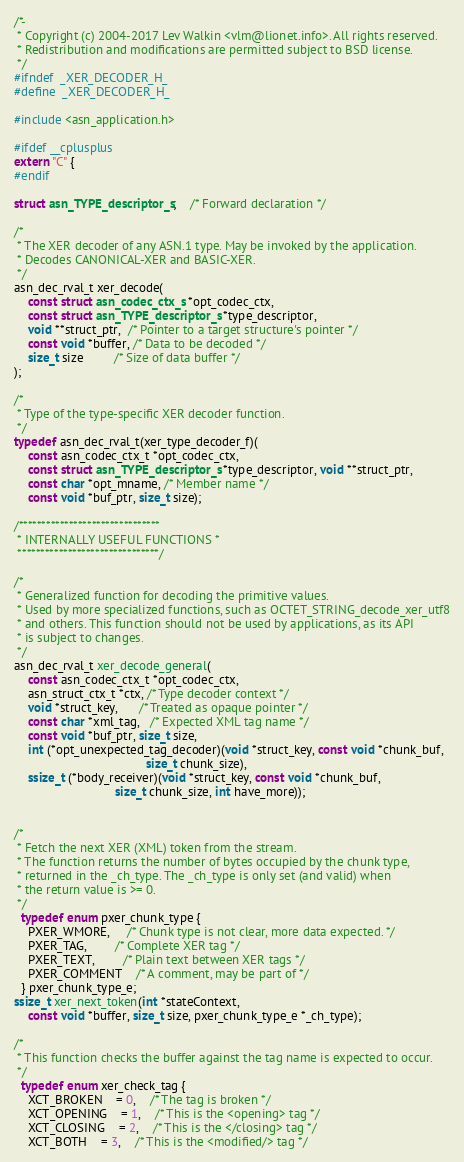<code> <loc_0><loc_0><loc_500><loc_500><_C_>
/*-
 * Copyright (c) 2004-2017 Lev Walkin <vlm@lionet.info>. All rights reserved.
 * Redistribution and modifications are permitted subject to BSD license.
 */
#ifndef	_XER_DECODER_H_
#define	_XER_DECODER_H_

#include <asn_application.h>

#ifdef __cplusplus
extern "C" {
#endif

struct asn_TYPE_descriptor_s;	/* Forward declaration */

/*
 * The XER decoder of any ASN.1 type. May be invoked by the application.
 * Decodes CANONICAL-XER and BASIC-XER.
 */
asn_dec_rval_t xer_decode(
    const struct asn_codec_ctx_s *opt_codec_ctx,
    const struct asn_TYPE_descriptor_s *type_descriptor,
    void **struct_ptr,  /* Pointer to a target structure's pointer */
    const void *buffer, /* Data to be decoded */
    size_t size         /* Size of data buffer */
);

/*
 * Type of the type-specific XER decoder function.
 */
typedef asn_dec_rval_t(xer_type_decoder_f)(
    const asn_codec_ctx_t *opt_codec_ctx,
    const struct asn_TYPE_descriptor_s *type_descriptor, void **struct_ptr,
    const char *opt_mname, /* Member name */
    const void *buf_ptr, size_t size);

/*******************************
 * INTERNALLY USEFUL FUNCTIONS *
 *******************************/

/*
 * Generalized function for decoding the primitive values.
 * Used by more specialized functions, such as OCTET_STRING_decode_xer_utf8
 * and others. This function should not be used by applications, as its API
 * is subject to changes.
 */
asn_dec_rval_t xer_decode_general(
    const asn_codec_ctx_t *opt_codec_ctx,
    asn_struct_ctx_t *ctx, /* Type decoder context */
    void *struct_key,      /* Treated as opaque pointer */
    const char *xml_tag,   /* Expected XML tag name */
    const void *buf_ptr, size_t size,
    int (*opt_unexpected_tag_decoder)(void *struct_key, const void *chunk_buf,
                                      size_t chunk_size),
    ssize_t (*body_receiver)(void *struct_key, const void *chunk_buf,
                             size_t chunk_size, int have_more));


/*
 * Fetch the next XER (XML) token from the stream.
 * The function returns the number of bytes occupied by the chunk type,
 * returned in the _ch_type. The _ch_type is only set (and valid) when
 * the return value is >= 0.
 */
  typedef enum pxer_chunk_type {
	PXER_WMORE,     /* Chunk type is not clear, more data expected. */
	PXER_TAG,	    /* Complete XER tag */
	PXER_TEXT,	    /* Plain text between XER tags */
	PXER_COMMENT	/* A comment, may be part of */
  } pxer_chunk_type_e;
ssize_t xer_next_token(int *stateContext,
	const void *buffer, size_t size, pxer_chunk_type_e *_ch_type);

/*
 * This function checks the buffer against the tag name is expected to occur.
 */
  typedef enum xer_check_tag {
	XCT_BROKEN	= 0,	/* The tag is broken */
	XCT_OPENING	= 1,	/* This is the <opening> tag */
	XCT_CLOSING	= 2,	/* This is the </closing> tag */
	XCT_BOTH	= 3,	/* This is the <modified/> tag */</code> 